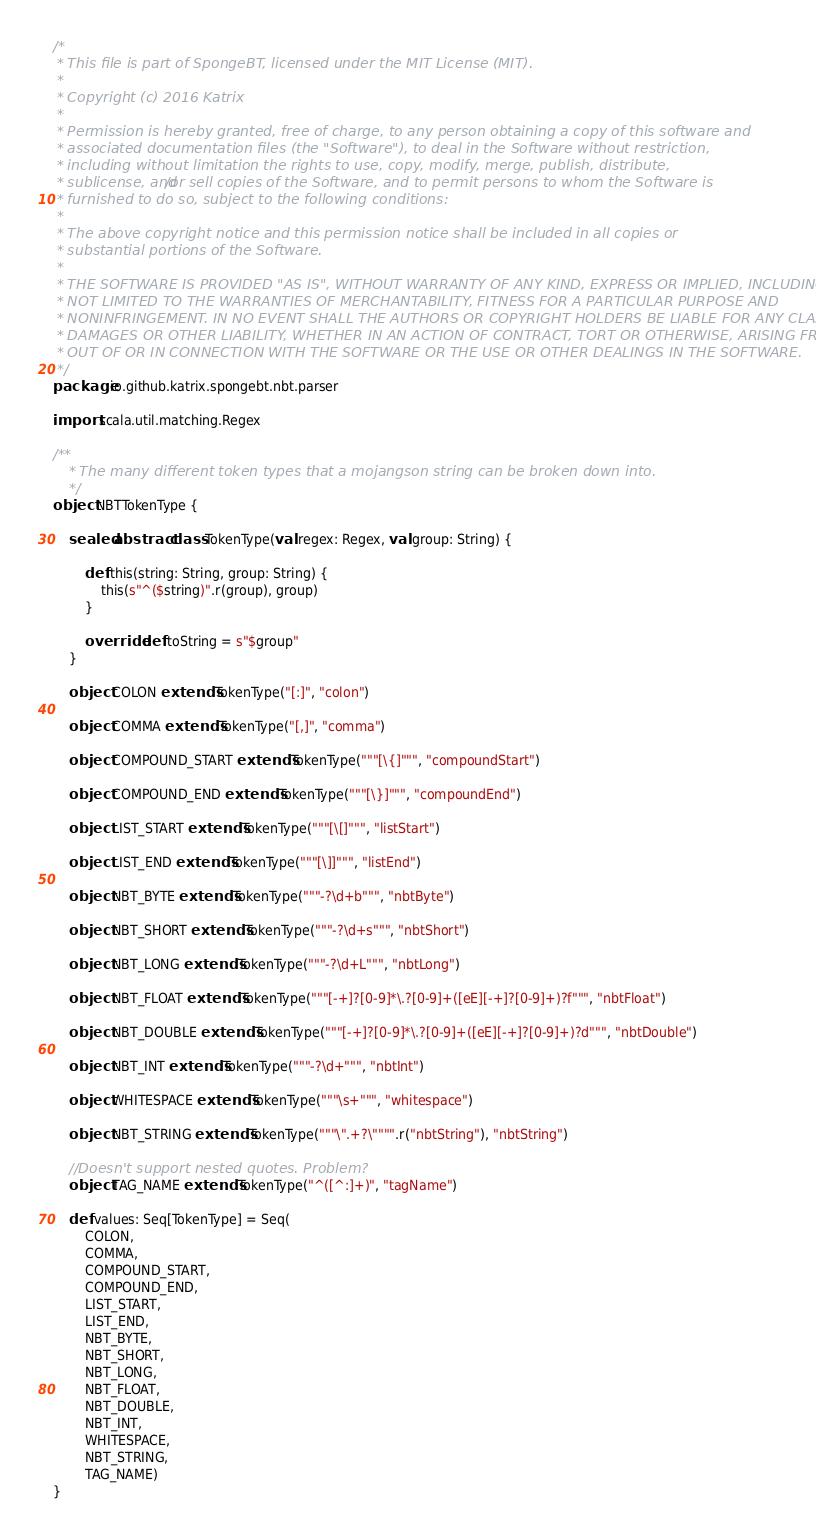Convert code to text. <code><loc_0><loc_0><loc_500><loc_500><_Scala_>/*
 * This file is part of SpongeBT, licensed under the MIT License (MIT).
 *
 * Copyright (c) 2016 Katrix
 *
 * Permission is hereby granted, free of charge, to any person obtaining a copy of this software and
 * associated documentation files (the "Software"), to deal in the Software without restriction,
 * including without limitation the rights to use, copy, modify, merge, publish, distribute,
 * sublicense, and/or sell copies of the Software, and to permit persons to whom the Software is
 * furnished to do so, subject to the following conditions:
 *
 * The above copyright notice and this permission notice shall be included in all copies or
 * substantial portions of the Software.
 *
 * THE SOFTWARE IS PROVIDED "AS IS", WITHOUT WARRANTY OF ANY KIND, EXPRESS OR IMPLIED, INCLUDING BUT
 * NOT LIMITED TO THE WARRANTIES OF MERCHANTABILITY, FITNESS FOR A PARTICULAR PURPOSE AND
 * NONINFRINGEMENT. IN NO EVENT SHALL THE AUTHORS OR COPYRIGHT HOLDERS BE LIABLE FOR ANY CLAIM,
 * DAMAGES OR OTHER LIABILITY, WHETHER IN AN ACTION OF CONTRACT, TORT OR OTHERWISE, ARISING FROM,
 * OUT OF OR IN CONNECTION WITH THE SOFTWARE OR THE USE OR OTHER DEALINGS IN THE SOFTWARE.
 */
package io.github.katrix.spongebt.nbt.parser

import scala.util.matching.Regex

/**
	* The many different token types that a mojangson string can be broken down into.
	*/
object NBTTokenType {

	sealed abstract class TokenType(val regex: Regex, val group: String) {

		def this(string: String, group: String) {
			this(s"^($string)".r(group), group)
		}

		override def toString = s"$group"
	}

	object COLON extends TokenType("[:]", "colon")

	object COMMA extends TokenType("[,]", "comma")

	object COMPOUND_START extends TokenType("""[\{]""", "compoundStart")

	object COMPOUND_END extends TokenType("""[\}]""", "compoundEnd")

	object LIST_START extends TokenType("""[\[]""", "listStart")

	object LIST_END extends TokenType("""[\]]""", "listEnd")

	object NBT_BYTE extends TokenType("""-?\d+b""", "nbtByte")

	object NBT_SHORT extends TokenType("""-?\d+s""", "nbtShort")

	object NBT_LONG extends TokenType("""-?\d+L""", "nbtLong")

	object NBT_FLOAT extends TokenType("""[-+]?[0-9]*\.?[0-9]+([eE][-+]?[0-9]+)?f""", "nbtFloat")

	object NBT_DOUBLE extends TokenType("""[-+]?[0-9]*\.?[0-9]+([eE][-+]?[0-9]+)?d""", "nbtDouble")

	object NBT_INT extends TokenType("""-?\d+""", "nbtInt")

	object WHITESPACE extends TokenType("""\s+""", "whitespace")

	object NBT_STRING extends TokenType("""\".+?\"""".r("nbtString"), "nbtString")

	//Doesn't support nested quotes. Problem?
	object TAG_NAME extends TokenType("^([^:]+)", "tagName")

	def values: Seq[TokenType] = Seq(
		COLON,
		COMMA,
		COMPOUND_START,
		COMPOUND_END,
		LIST_START,
		LIST_END,
		NBT_BYTE,
		NBT_SHORT,
		NBT_LONG,
		NBT_FLOAT,
		NBT_DOUBLE,
		NBT_INT,
		WHITESPACE,
		NBT_STRING,
		TAG_NAME)
}</code> 